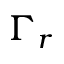<formula> <loc_0><loc_0><loc_500><loc_500>\Gamma _ { r }</formula> 